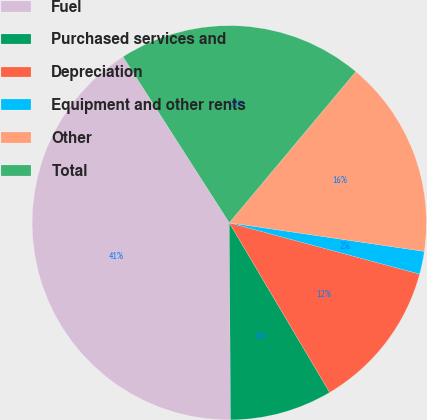<chart> <loc_0><loc_0><loc_500><loc_500><pie_chart><fcel>Fuel<fcel>Purchased services and<fcel>Depreciation<fcel>Equipment and other rents<fcel>Other<fcel>Total<nl><fcel>41.04%<fcel>8.4%<fcel>12.31%<fcel>1.87%<fcel>16.23%<fcel>20.15%<nl></chart> 